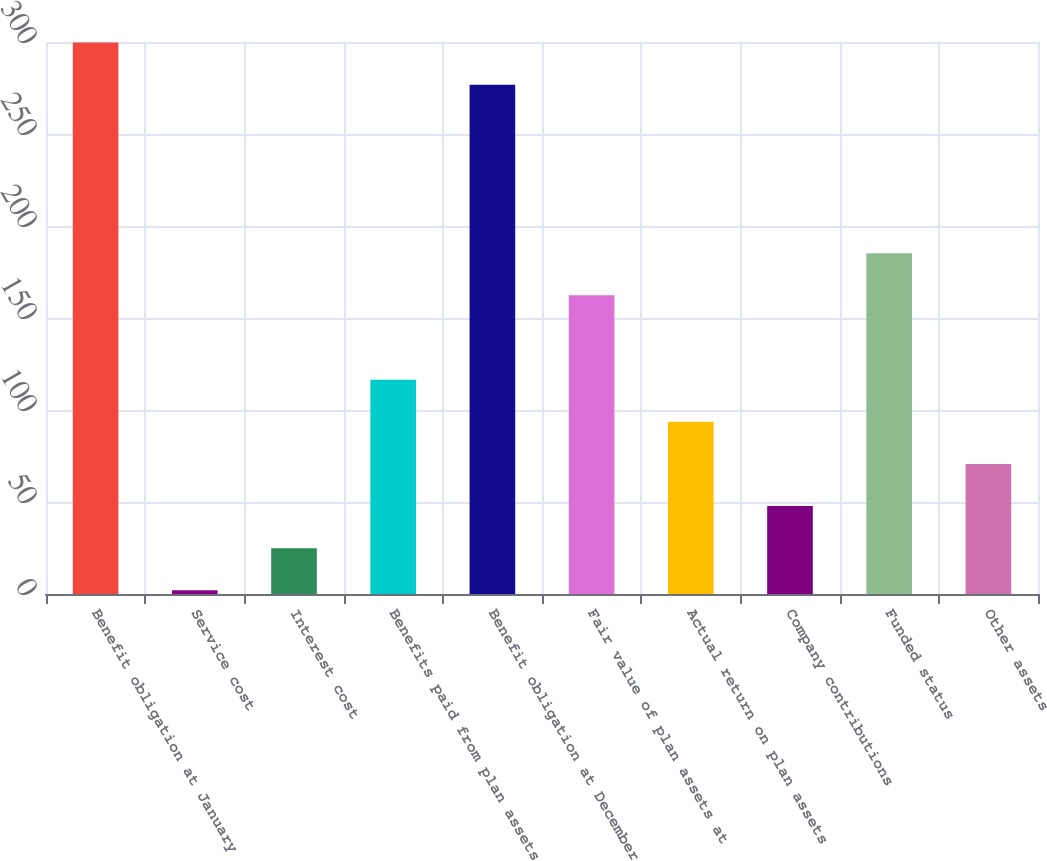Convert chart. <chart><loc_0><loc_0><loc_500><loc_500><bar_chart><fcel>Benefit obligation at January<fcel>Service cost<fcel>Interest cost<fcel>Benefits paid from plan assets<fcel>Benefit obligation at December<fcel>Fair value of plan assets at<fcel>Actual return on plan assets<fcel>Company contributions<fcel>Funded status<fcel>Other assets<nl><fcel>299.7<fcel>2<fcel>24.9<fcel>116.5<fcel>276.8<fcel>162.3<fcel>93.6<fcel>47.8<fcel>185.2<fcel>70.7<nl></chart> 